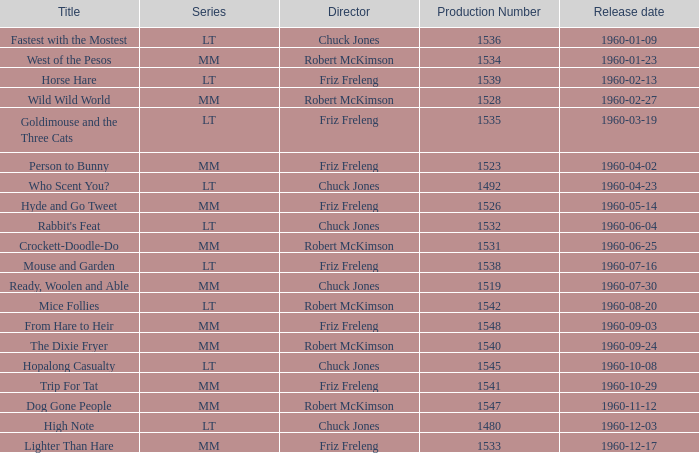What is the Series number of the episode with a production number of 1547? MM. 